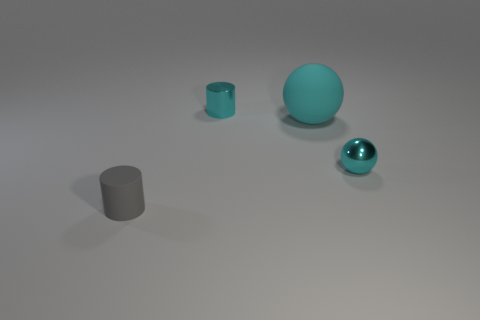There is a small cylinder that is in front of the metal sphere; what is its color?
Offer a terse response. Gray. Are there any small shiny balls that are left of the object behind the large object?
Your response must be concise. No. There is a small matte thing; is it the same color as the object behind the large cyan matte sphere?
Offer a terse response. No. Are there any big gray blocks made of the same material as the cyan cylinder?
Keep it short and to the point. No. How many small rubber cylinders are there?
Make the answer very short. 1. There is a small cylinder behind the cyan metallic thing on the right side of the tiny metallic cylinder; what is its material?
Provide a succinct answer. Metal. There is a small thing that is made of the same material as the cyan cylinder; what is its color?
Your answer should be very brief. Cyan. There is a rubber object that is the same color as the shiny cylinder; what shape is it?
Ensure brevity in your answer.  Sphere. There is a rubber object that is to the right of the tiny gray matte cylinder; is it the same size as the cylinder on the left side of the tiny cyan cylinder?
Make the answer very short. No. How many spheres are either gray objects or purple matte objects?
Your answer should be compact. 0. 